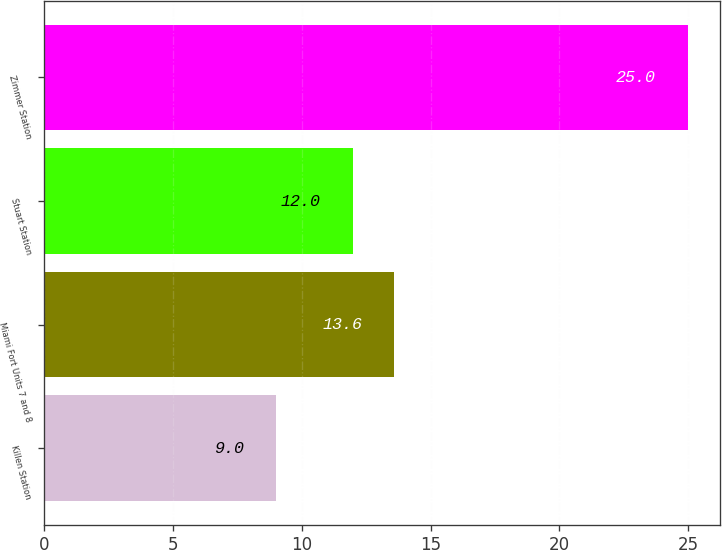Convert chart to OTSL. <chart><loc_0><loc_0><loc_500><loc_500><bar_chart><fcel>Killen Station<fcel>Miami Fort Units 7 and 8<fcel>Stuart Station<fcel>Zimmer Station<nl><fcel>9<fcel>13.6<fcel>12<fcel>25<nl></chart> 